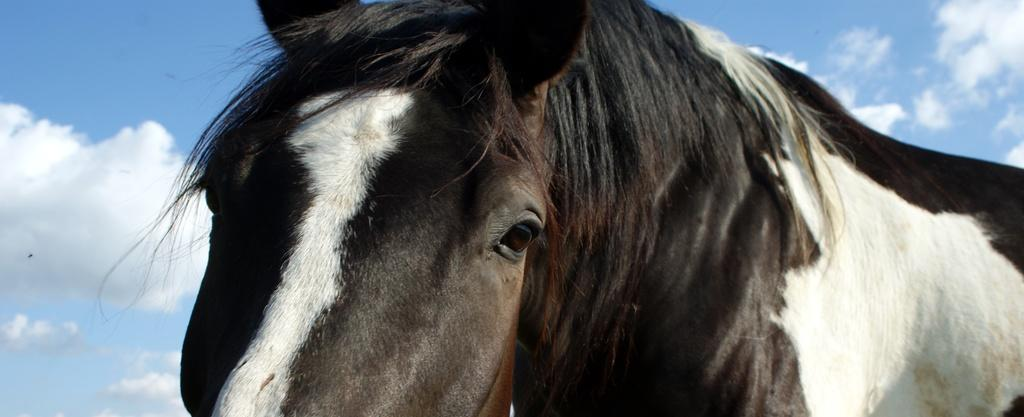What animal is present in the image? There is a horse in the image. What colors can be seen on the horse? The horse is black and white. What type of car can be seen in the image? There is no car present in the image; it features a black and white horse. How many volleyballs are visible in the image? There are no volleyballs present in the image. 